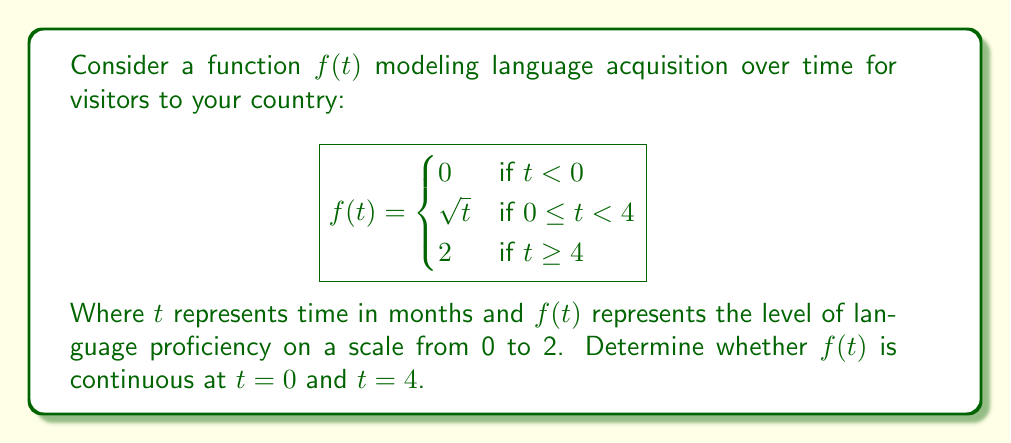Can you answer this question? To determine the continuity of $f(t)$ at $t = 0$ and $t = 4$, we need to check if the function satisfies the three conditions for continuity at these points:

1. The function must be defined at the point.
2. The limit of the function as we approach the point from both sides must exist.
3. The limit must equal the function value at that point.

For $t = 0$:

1. $f(0)$ is defined and equals 0.
2. Left-hand limit: $\lim_{t \to 0^-} f(t) = 0$
   Right-hand limit: $\lim_{t \to 0^+} f(t) = \lim_{t \to 0^+} \sqrt{t} = 0$
3. $\lim_{t \to 0} f(t) = f(0) = 0$

All three conditions are satisfied, so $f(t)$ is continuous at $t = 0$.

For $t = 4$:

1. $f(4)$ is defined and equals 2.
2. Left-hand limit: $\lim_{t \to 4^-} f(t) = \lim_{t \to 4^-} \sqrt{t} = 2$
   Right-hand limit: $\lim_{t \to 4^+} f(t) = 2$
3. $\lim_{t \to 4} f(t) = f(4) = 2$

All three conditions are satisfied, so $f(t)$ is continuous at $t = 4$.
Answer: $f(t)$ is continuous at both $t = 0$ and $t = 4$. 